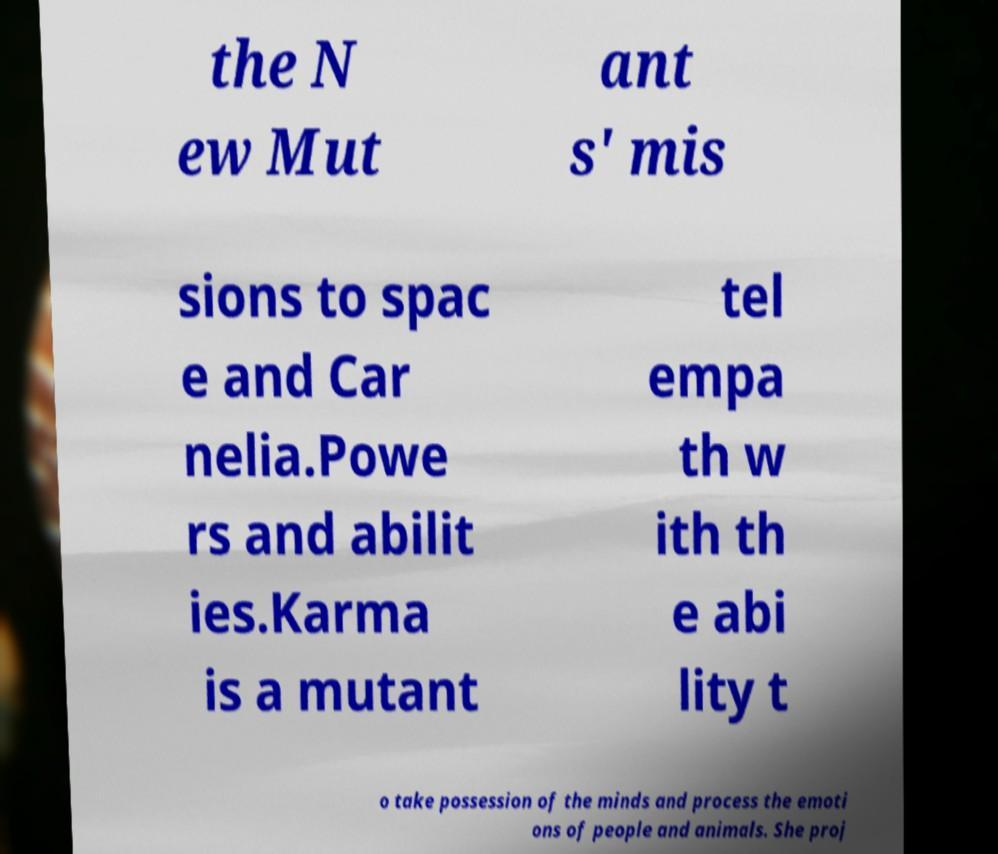Can you read and provide the text displayed in the image?This photo seems to have some interesting text. Can you extract and type it out for me? the N ew Mut ant s' mis sions to spac e and Car nelia.Powe rs and abilit ies.Karma is a mutant tel empa th w ith th e abi lity t o take possession of the minds and process the emoti ons of people and animals. She proj 